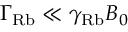Convert formula to latex. <formula><loc_0><loc_0><loc_500><loc_500>\Gamma _ { R b } \ll \gamma _ { R b } B _ { 0 }</formula> 